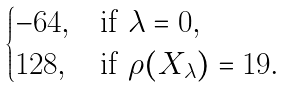Convert formula to latex. <formula><loc_0><loc_0><loc_500><loc_500>\begin{cases} - 6 4 , & \text {if } \lambda = 0 , \\ 1 2 8 , & \text {if } \rho ( X _ { \lambda } ) = 1 9 . \end{cases}</formula> 